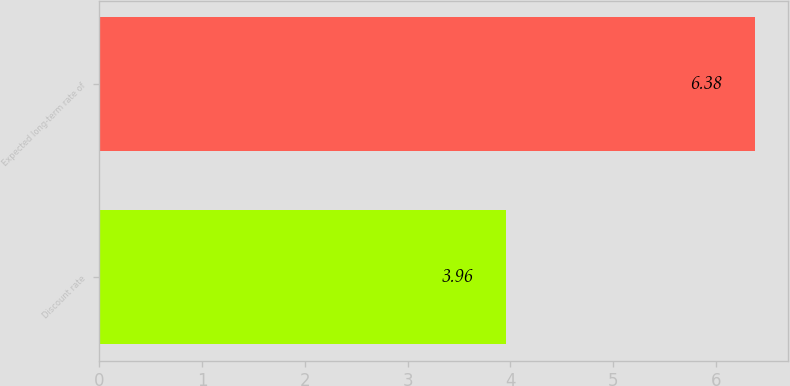<chart> <loc_0><loc_0><loc_500><loc_500><bar_chart><fcel>Discount rate<fcel>Expected long-term rate of<nl><fcel>3.96<fcel>6.38<nl></chart> 